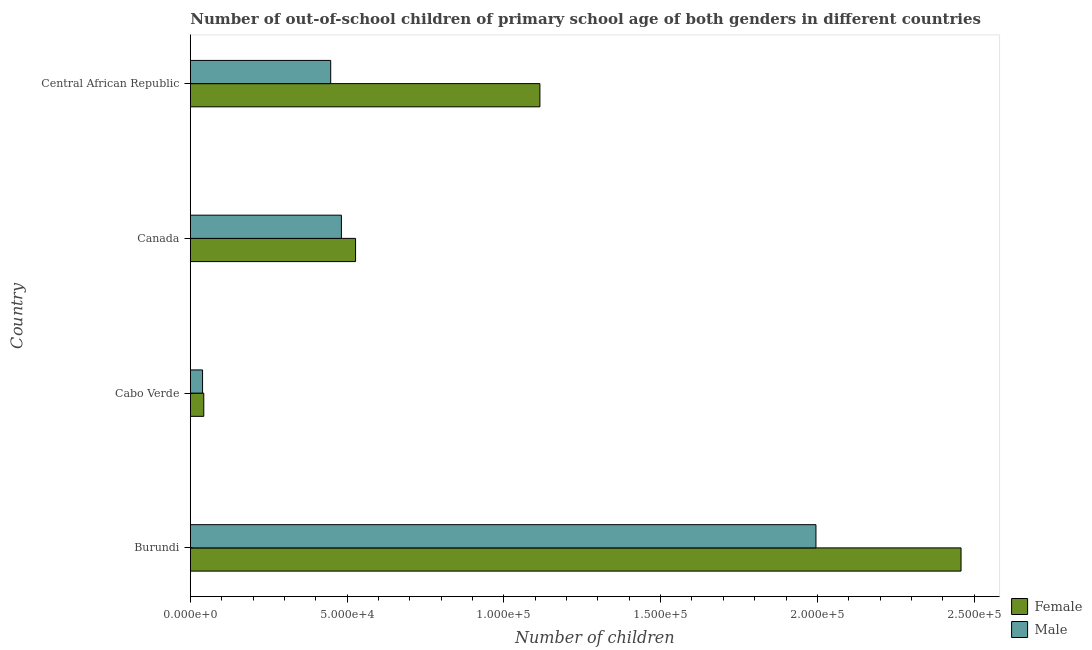How many different coloured bars are there?
Your answer should be compact. 2. How many groups of bars are there?
Keep it short and to the point. 4. Are the number of bars per tick equal to the number of legend labels?
Your answer should be compact. Yes. What is the label of the 2nd group of bars from the top?
Your answer should be compact. Canada. In how many cases, is the number of bars for a given country not equal to the number of legend labels?
Your answer should be compact. 0. What is the number of female out-of-school students in Canada?
Make the answer very short. 5.27e+04. Across all countries, what is the maximum number of male out-of-school students?
Give a very brief answer. 2.00e+05. Across all countries, what is the minimum number of female out-of-school students?
Offer a very short reply. 4299. In which country was the number of female out-of-school students maximum?
Offer a very short reply. Burundi. In which country was the number of male out-of-school students minimum?
Your response must be concise. Cabo Verde. What is the total number of male out-of-school students in the graph?
Offer a very short reply. 2.96e+05. What is the difference between the number of male out-of-school students in Cabo Verde and that in Canada?
Keep it short and to the point. -4.43e+04. What is the difference between the number of female out-of-school students in Central African Republic and the number of male out-of-school students in Canada?
Your response must be concise. 6.33e+04. What is the average number of male out-of-school students per country?
Provide a succinct answer. 7.41e+04. What is the difference between the number of male out-of-school students and number of female out-of-school students in Burundi?
Offer a very short reply. -4.63e+04. In how many countries, is the number of male out-of-school students greater than 120000 ?
Provide a short and direct response. 1. What is the ratio of the number of female out-of-school students in Cabo Verde to that in Central African Republic?
Keep it short and to the point. 0.04. Is the number of male out-of-school students in Burundi less than that in Cabo Verde?
Provide a succinct answer. No. Is the difference between the number of male out-of-school students in Burundi and Central African Republic greater than the difference between the number of female out-of-school students in Burundi and Central African Republic?
Offer a very short reply. Yes. What is the difference between the highest and the second highest number of male out-of-school students?
Your response must be concise. 1.51e+05. What is the difference between the highest and the lowest number of female out-of-school students?
Give a very brief answer. 2.42e+05. Is the sum of the number of male out-of-school students in Canada and Central African Republic greater than the maximum number of female out-of-school students across all countries?
Offer a very short reply. No. What does the 2nd bar from the bottom in Cabo Verde represents?
Offer a very short reply. Male. How many bars are there?
Offer a very short reply. 8. What is the difference between two consecutive major ticks on the X-axis?
Offer a very short reply. 5.00e+04. Does the graph contain grids?
Keep it short and to the point. No. Where does the legend appear in the graph?
Provide a short and direct response. Bottom right. How many legend labels are there?
Your answer should be compact. 2. What is the title of the graph?
Offer a very short reply. Number of out-of-school children of primary school age of both genders in different countries. Does "Public funds" appear as one of the legend labels in the graph?
Your answer should be very brief. No. What is the label or title of the X-axis?
Your answer should be compact. Number of children. What is the Number of children in Female in Burundi?
Provide a short and direct response. 2.46e+05. What is the Number of children in Male in Burundi?
Your answer should be very brief. 2.00e+05. What is the Number of children in Female in Cabo Verde?
Your response must be concise. 4299. What is the Number of children in Male in Cabo Verde?
Provide a short and direct response. 3912. What is the Number of children of Female in Canada?
Your answer should be very brief. 5.27e+04. What is the Number of children of Male in Canada?
Give a very brief answer. 4.82e+04. What is the Number of children in Female in Central African Republic?
Give a very brief answer. 1.12e+05. What is the Number of children in Male in Central African Republic?
Make the answer very short. 4.48e+04. Across all countries, what is the maximum Number of children in Female?
Give a very brief answer. 2.46e+05. Across all countries, what is the maximum Number of children of Male?
Offer a terse response. 2.00e+05. Across all countries, what is the minimum Number of children in Female?
Ensure brevity in your answer.  4299. Across all countries, what is the minimum Number of children of Male?
Offer a terse response. 3912. What is the total Number of children of Female in the graph?
Offer a very short reply. 4.14e+05. What is the total Number of children of Male in the graph?
Make the answer very short. 2.96e+05. What is the difference between the Number of children of Female in Burundi and that in Cabo Verde?
Make the answer very short. 2.42e+05. What is the difference between the Number of children of Male in Burundi and that in Cabo Verde?
Keep it short and to the point. 1.96e+05. What is the difference between the Number of children in Female in Burundi and that in Canada?
Offer a very short reply. 1.93e+05. What is the difference between the Number of children of Male in Burundi and that in Canada?
Your answer should be compact. 1.51e+05. What is the difference between the Number of children in Female in Burundi and that in Central African Republic?
Provide a short and direct response. 1.34e+05. What is the difference between the Number of children of Male in Burundi and that in Central African Republic?
Offer a very short reply. 1.55e+05. What is the difference between the Number of children in Female in Cabo Verde and that in Canada?
Make the answer very short. -4.84e+04. What is the difference between the Number of children of Male in Cabo Verde and that in Canada?
Offer a very short reply. -4.43e+04. What is the difference between the Number of children of Female in Cabo Verde and that in Central African Republic?
Your answer should be very brief. -1.07e+05. What is the difference between the Number of children of Male in Cabo Verde and that in Central African Republic?
Offer a terse response. -4.09e+04. What is the difference between the Number of children in Female in Canada and that in Central African Republic?
Keep it short and to the point. -5.88e+04. What is the difference between the Number of children of Male in Canada and that in Central African Republic?
Keep it short and to the point. 3415. What is the difference between the Number of children in Female in Burundi and the Number of children in Male in Cabo Verde?
Your answer should be very brief. 2.42e+05. What is the difference between the Number of children in Female in Burundi and the Number of children in Male in Canada?
Keep it short and to the point. 1.98e+05. What is the difference between the Number of children in Female in Burundi and the Number of children in Male in Central African Republic?
Keep it short and to the point. 2.01e+05. What is the difference between the Number of children in Female in Cabo Verde and the Number of children in Male in Canada?
Provide a short and direct response. -4.39e+04. What is the difference between the Number of children of Female in Cabo Verde and the Number of children of Male in Central African Republic?
Your response must be concise. -4.05e+04. What is the difference between the Number of children in Female in Canada and the Number of children in Male in Central African Republic?
Ensure brevity in your answer.  7928. What is the average Number of children of Female per country?
Your answer should be compact. 1.04e+05. What is the average Number of children in Male per country?
Give a very brief answer. 7.41e+04. What is the difference between the Number of children of Female and Number of children of Male in Burundi?
Provide a short and direct response. 4.63e+04. What is the difference between the Number of children in Female and Number of children in Male in Cabo Verde?
Offer a terse response. 387. What is the difference between the Number of children in Female and Number of children in Male in Canada?
Your answer should be compact. 4513. What is the difference between the Number of children of Female and Number of children of Male in Central African Republic?
Offer a very short reply. 6.67e+04. What is the ratio of the Number of children in Female in Burundi to that in Cabo Verde?
Ensure brevity in your answer.  57.18. What is the ratio of the Number of children in Male in Burundi to that in Cabo Verde?
Make the answer very short. 51.01. What is the ratio of the Number of children in Female in Burundi to that in Canada?
Ensure brevity in your answer.  4.66. What is the ratio of the Number of children of Male in Burundi to that in Canada?
Your response must be concise. 4.14. What is the ratio of the Number of children in Female in Burundi to that in Central African Republic?
Keep it short and to the point. 2.2. What is the ratio of the Number of children of Male in Burundi to that in Central African Republic?
Provide a short and direct response. 4.46. What is the ratio of the Number of children in Female in Cabo Verde to that in Canada?
Make the answer very short. 0.08. What is the ratio of the Number of children of Male in Cabo Verde to that in Canada?
Provide a short and direct response. 0.08. What is the ratio of the Number of children of Female in Cabo Verde to that in Central African Republic?
Your answer should be very brief. 0.04. What is the ratio of the Number of children in Male in Cabo Verde to that in Central African Republic?
Keep it short and to the point. 0.09. What is the ratio of the Number of children of Female in Canada to that in Central African Republic?
Your answer should be compact. 0.47. What is the ratio of the Number of children in Male in Canada to that in Central African Republic?
Offer a terse response. 1.08. What is the difference between the highest and the second highest Number of children in Female?
Your answer should be very brief. 1.34e+05. What is the difference between the highest and the second highest Number of children in Male?
Make the answer very short. 1.51e+05. What is the difference between the highest and the lowest Number of children of Female?
Ensure brevity in your answer.  2.42e+05. What is the difference between the highest and the lowest Number of children of Male?
Ensure brevity in your answer.  1.96e+05. 